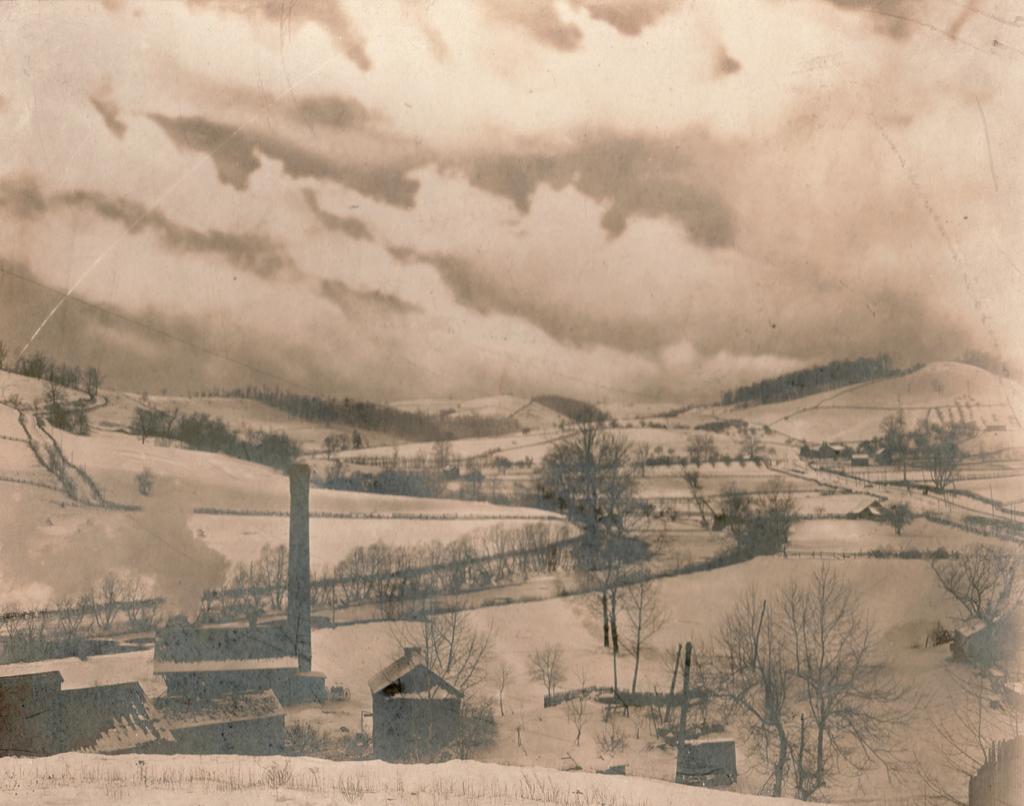Please provide a concise description of this image. As we can see in the image there is painting of houses and trees. There is sand and fence. At the top there is sky and clouds. 